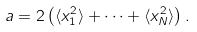<formula> <loc_0><loc_0><loc_500><loc_500>a = 2 \left ( \langle x _ { 1 } ^ { 2 } \rangle + \dots + \langle x _ { N } ^ { 2 } \rangle \right ) .</formula> 